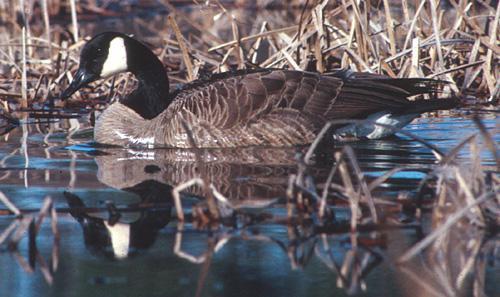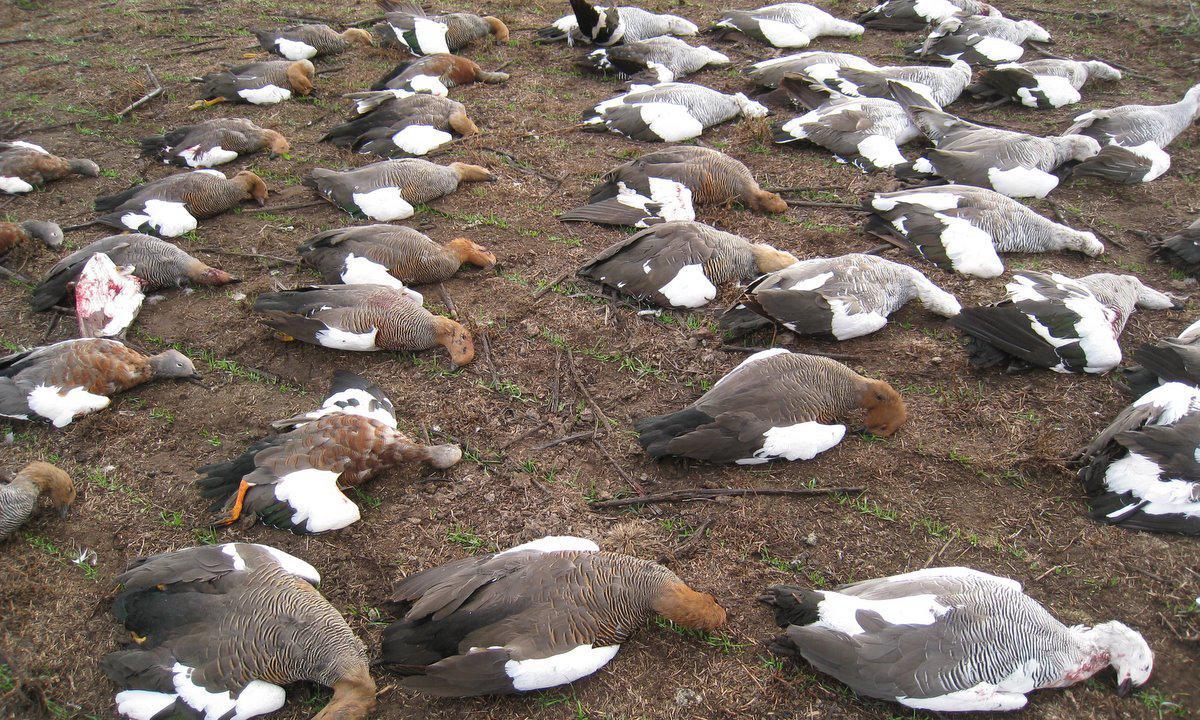The first image is the image on the left, the second image is the image on the right. Analyze the images presented: Is the assertion "At least one goose has a black neck and beak, and a grey body." valid? Answer yes or no. Yes. The first image is the image on the left, the second image is the image on the right. For the images displayed, is the sentence "In at least one image there are Blacked becked birds touching the water." factually correct? Answer yes or no. Yes. 